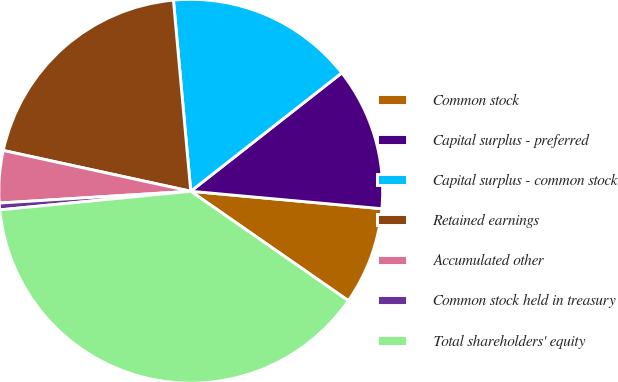<chart> <loc_0><loc_0><loc_500><loc_500><pie_chart><fcel>Common stock<fcel>Capital surplus - preferred<fcel>Capital surplus - common stock<fcel>Retained earnings<fcel>Accumulated other<fcel>Common stock held in treasury<fcel>Total shareholders' equity<nl><fcel>8.21%<fcel>12.03%<fcel>15.86%<fcel>20.15%<fcel>4.39%<fcel>0.57%<fcel>38.79%<nl></chart> 